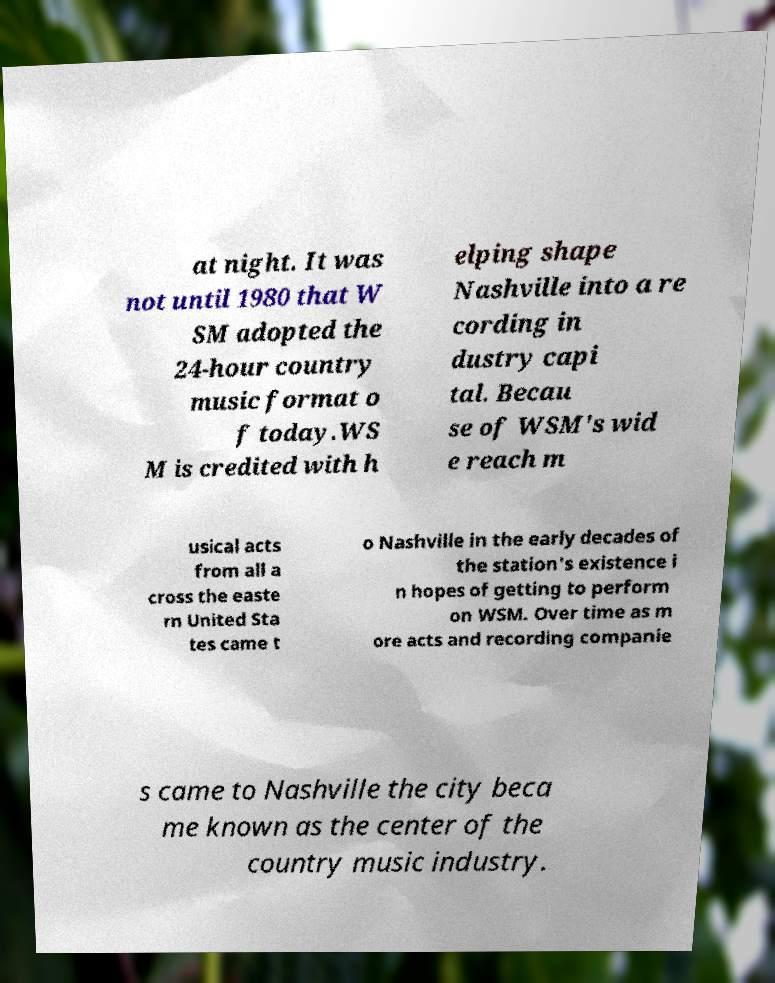For documentation purposes, I need the text within this image transcribed. Could you provide that? at night. It was not until 1980 that W SM adopted the 24-hour country music format o f today.WS M is credited with h elping shape Nashville into a re cording in dustry capi tal. Becau se of WSM's wid e reach m usical acts from all a cross the easte rn United Sta tes came t o Nashville in the early decades of the station's existence i n hopes of getting to perform on WSM. Over time as m ore acts and recording companie s came to Nashville the city beca me known as the center of the country music industry. 